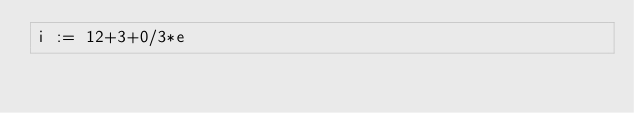<code> <loc_0><loc_0><loc_500><loc_500><_C_>i := 12+3+0/3*e</code> 